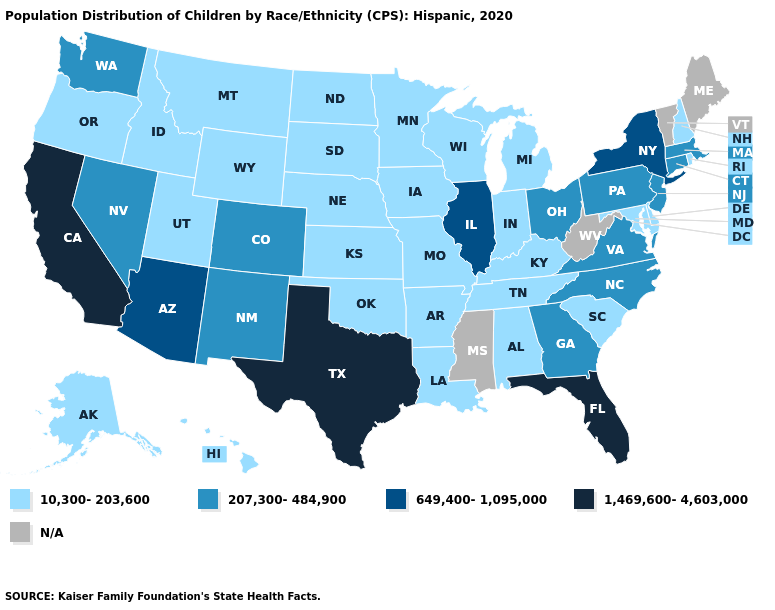Name the states that have a value in the range N/A?
Give a very brief answer. Maine, Mississippi, Vermont, West Virginia. What is the highest value in the MidWest ?
Concise answer only. 649,400-1,095,000. Which states have the lowest value in the Northeast?
Keep it brief. New Hampshire, Rhode Island. What is the lowest value in states that border Pennsylvania?
Write a very short answer. 10,300-203,600. Name the states that have a value in the range 649,400-1,095,000?
Be succinct. Arizona, Illinois, New York. Name the states that have a value in the range N/A?
Concise answer only. Maine, Mississippi, Vermont, West Virginia. What is the value of Maryland?
Give a very brief answer. 10,300-203,600. Name the states that have a value in the range 207,300-484,900?
Give a very brief answer. Colorado, Connecticut, Georgia, Massachusetts, Nevada, New Jersey, New Mexico, North Carolina, Ohio, Pennsylvania, Virginia, Washington. Name the states that have a value in the range 649,400-1,095,000?
Concise answer only. Arizona, Illinois, New York. What is the value of Virginia?
Answer briefly. 207,300-484,900. What is the lowest value in the USA?
Short answer required. 10,300-203,600. Name the states that have a value in the range N/A?
Write a very short answer. Maine, Mississippi, Vermont, West Virginia. 